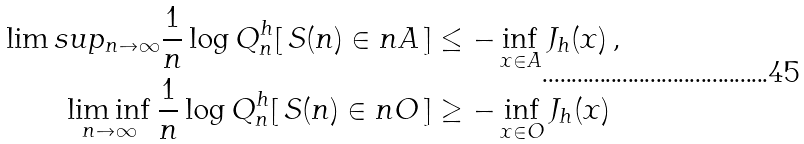<formula> <loc_0><loc_0><loc_500><loc_500>\lim s u p _ { n \to \infty } \frac { 1 } { n } \log Q ^ { h } _ { n } [ \, S ( n ) \in n A \, ] & \leq - \inf _ { x \in A } J _ { h } ( x ) \, , \\ \liminf _ { n \to \infty } \frac { 1 } { n } \log Q ^ { h } _ { n } [ \, S ( n ) \in n O \, ] & \geq - \inf _ { x \in O } J _ { h } ( x )</formula> 